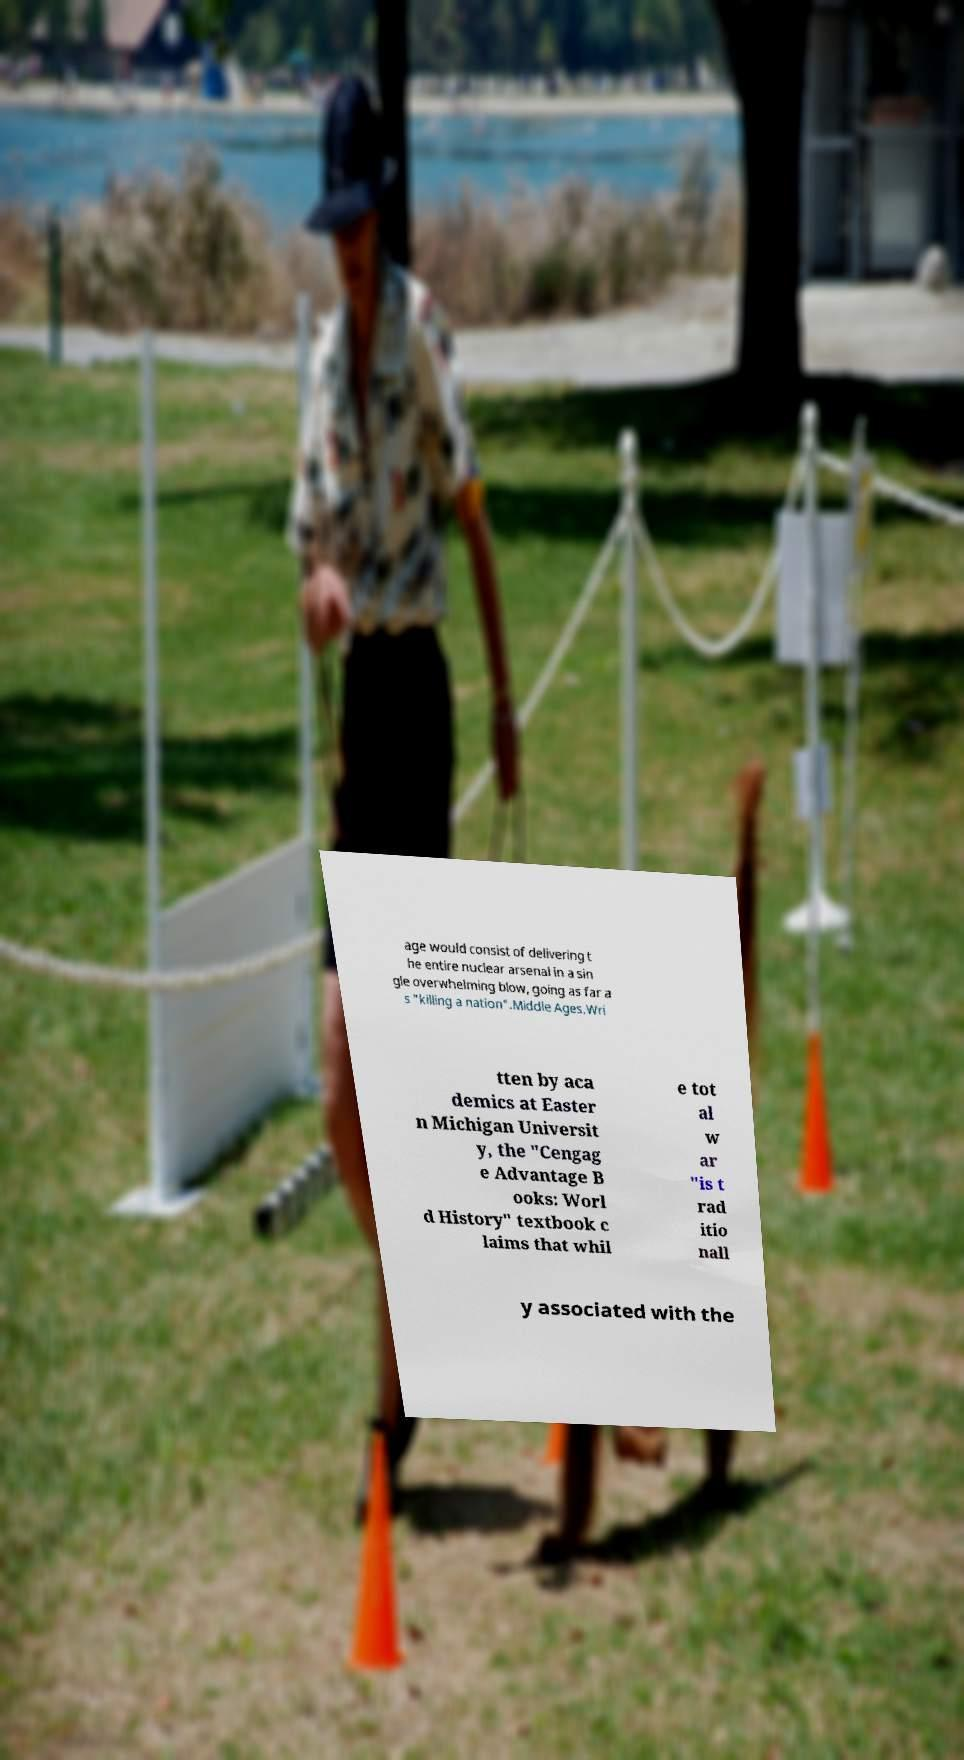I need the written content from this picture converted into text. Can you do that? age would consist of delivering t he entire nuclear arsenal in a sin gle overwhelming blow, going as far a s "killing a nation".Middle Ages.Wri tten by aca demics at Easter n Michigan Universit y, the "Cengag e Advantage B ooks: Worl d History" textbook c laims that whil e tot al w ar "is t rad itio nall y associated with the 